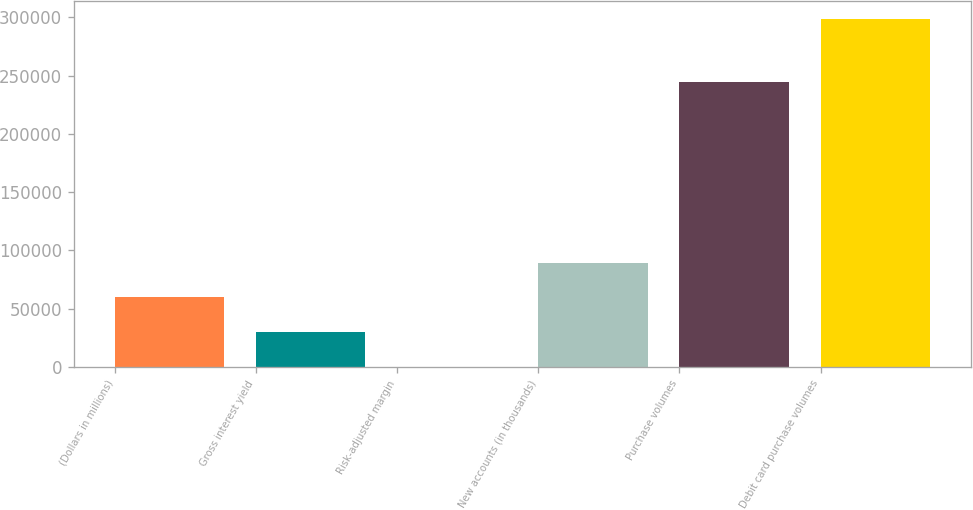Convert chart. <chart><loc_0><loc_0><loc_500><loc_500><bar_chart><fcel>(Dollars in millions)<fcel>Gross interest yield<fcel>Risk-adjusted margin<fcel>New accounts (in thousands)<fcel>Purchase volumes<fcel>Debit card purchase volumes<nl><fcel>59735.1<fcel>29871.9<fcel>8.67<fcel>89598.4<fcel>244753<fcel>298641<nl></chart> 